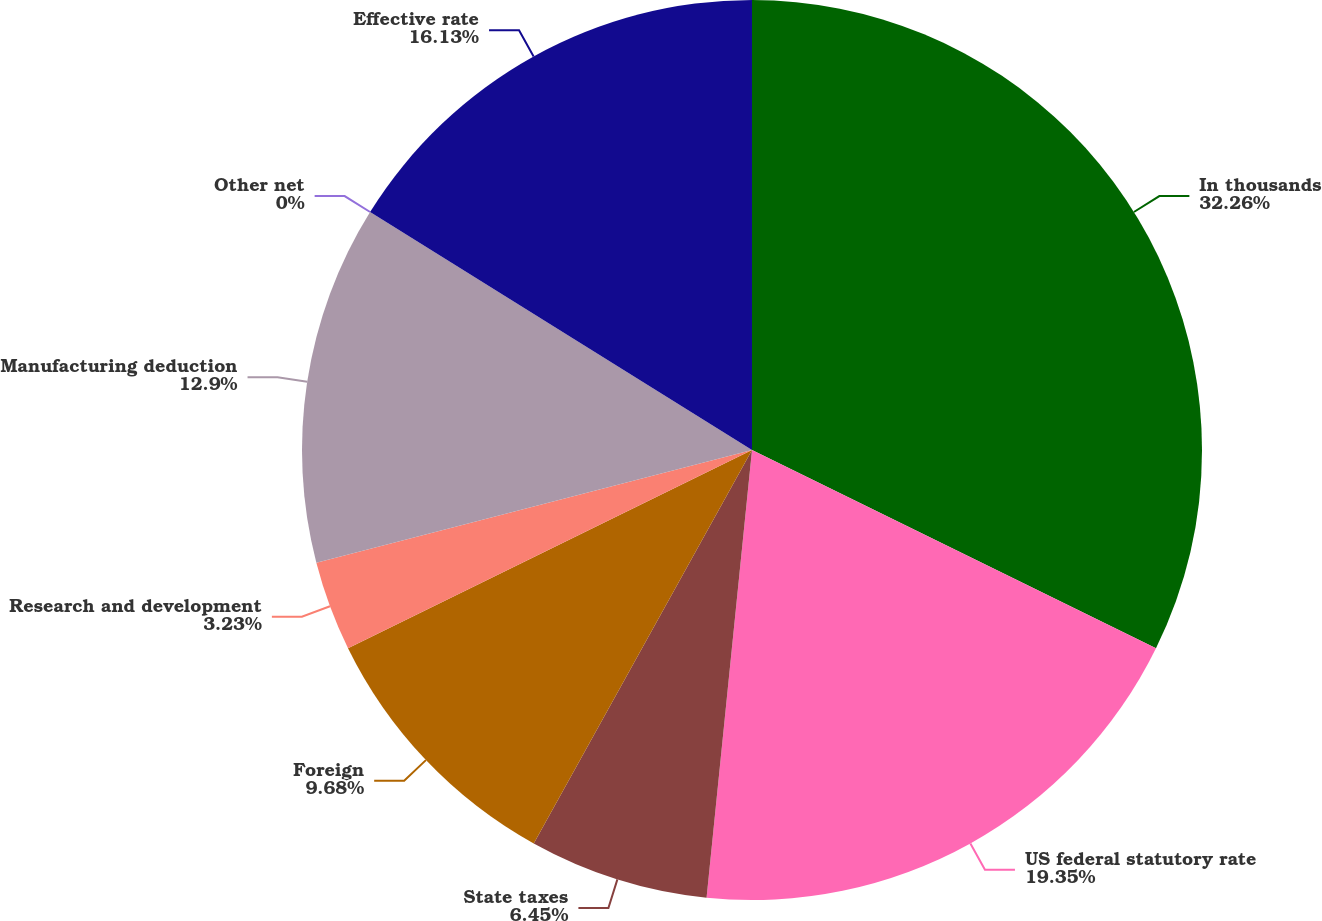Convert chart. <chart><loc_0><loc_0><loc_500><loc_500><pie_chart><fcel>In thousands<fcel>US federal statutory rate<fcel>State taxes<fcel>Foreign<fcel>Research and development<fcel>Manufacturing deduction<fcel>Other net<fcel>Effective rate<nl><fcel>32.26%<fcel>19.35%<fcel>6.45%<fcel>9.68%<fcel>3.23%<fcel>12.9%<fcel>0.0%<fcel>16.13%<nl></chart> 